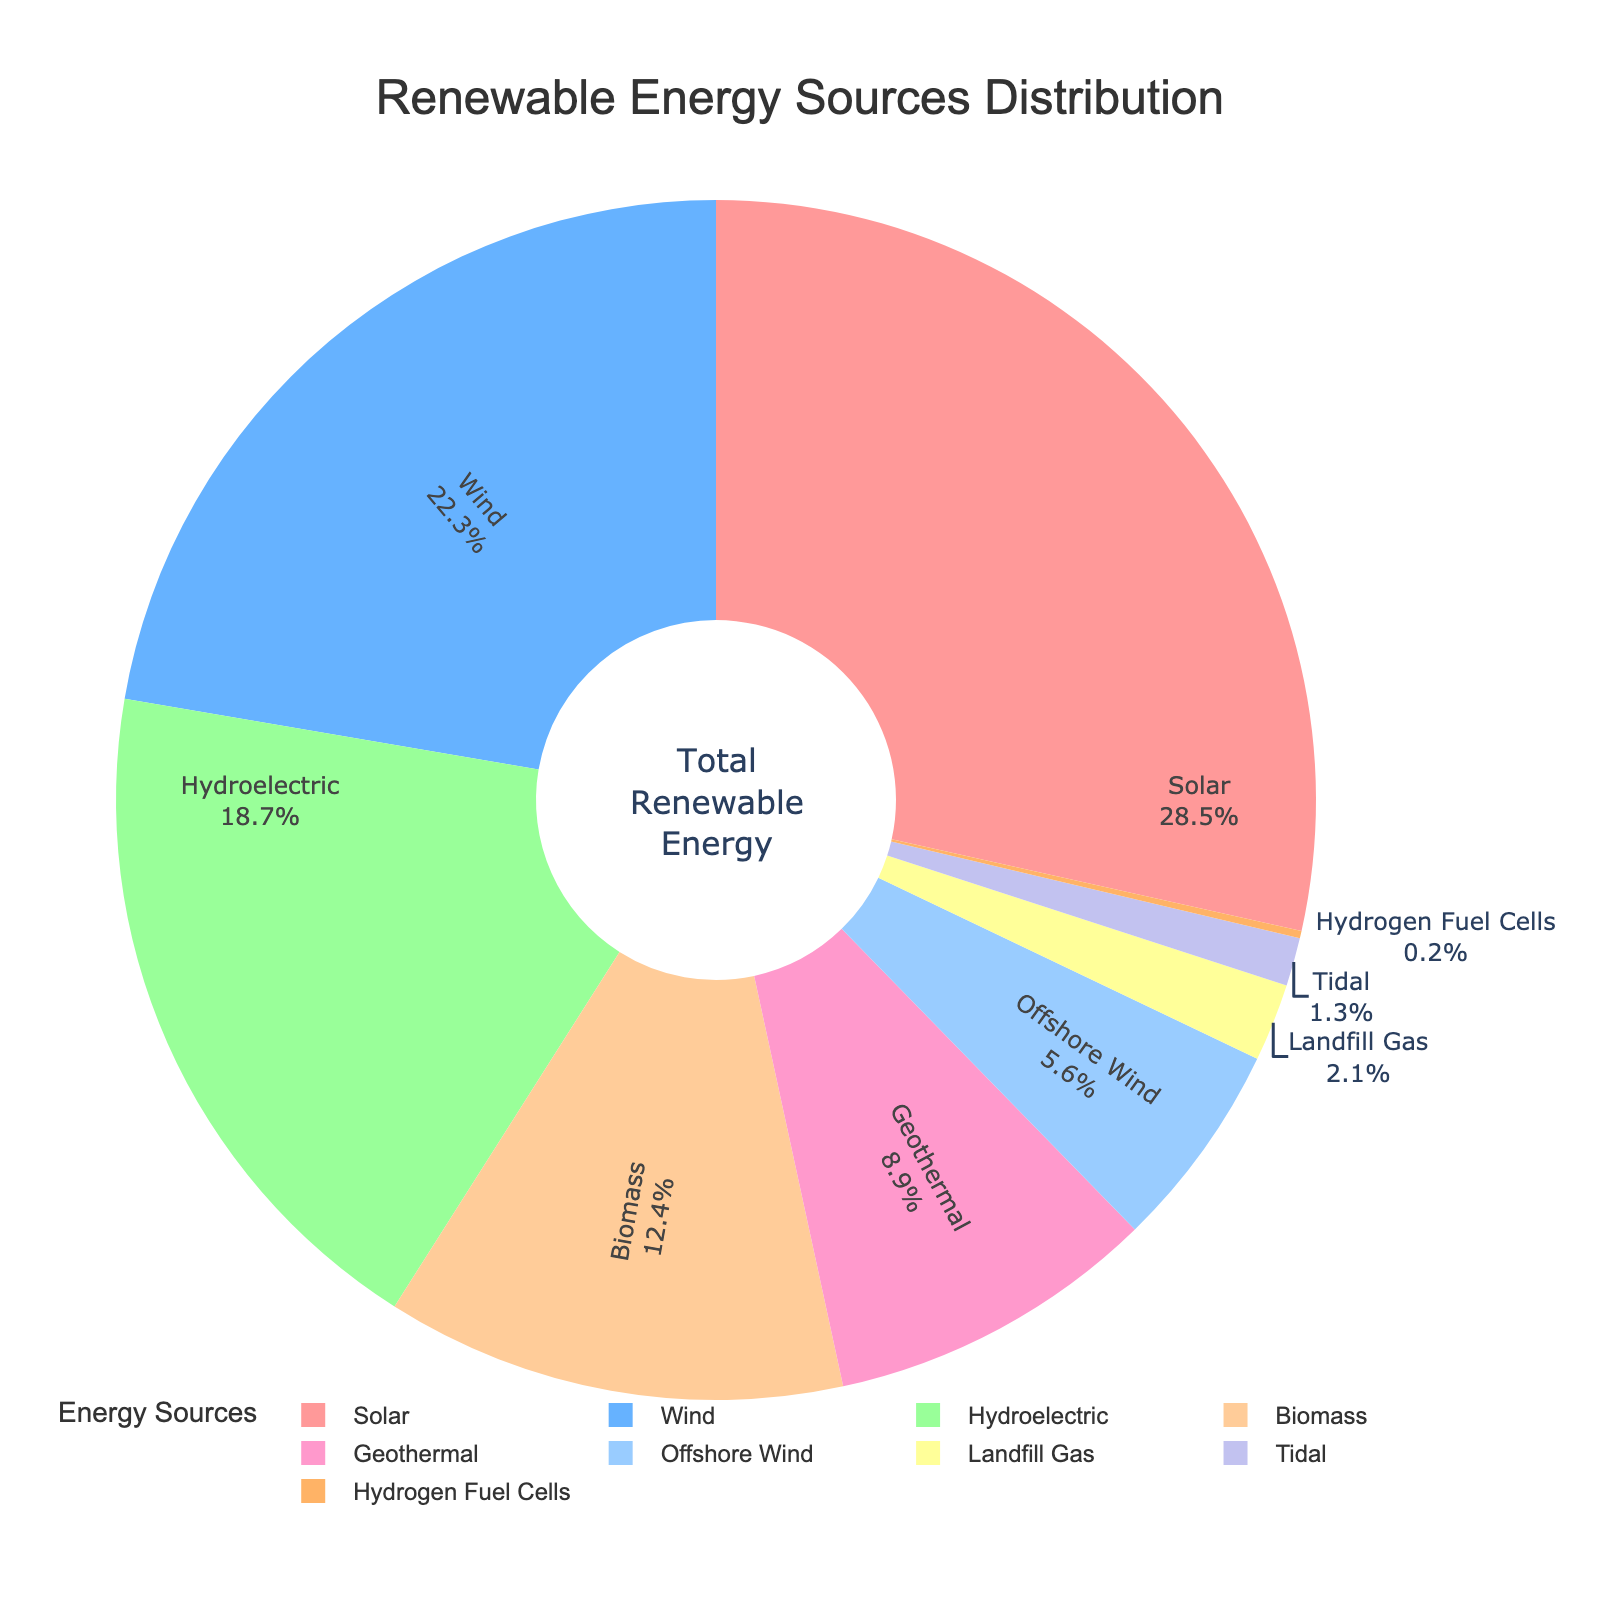Which energy source contributes the highest percentage? The pie chart shows the distribution of renewable energy sources. The segment with the largest percentage represents the highest contributor.
Answer: Solar What's the combined percentage of Wind and Offshore Wind? From the chart, Wind contributes 22.3% and Offshore Wind contributes 5.6%. Adding these percentages gives the total contribution. 22.3% + 5.6%
Answer: 27.9% Is Biomass contributing more or less than Geothermal? Biomass (12.4%) and Geothermal (8.9%) percentages can be compared directly from the chart.
Answer: More What is the difference in percentage between Solar and Hydroelectric? Solar contributes 28.5% and Hydroelectric 18.7%, the difference is calculated by subtracting Hydroelectric from Solar. 28.5% - 18.7%
Answer: 9.8% Which energy source, among the least contributors (below 3%), has the lowest percentage? The chart shows the contributions of Landfill Gas (2.1%), Tidal (1.3%), and Hydrogen Fuel Cells (0.2%). The smallest number among these is identified.
Answer: Hydrogen Fuel Cells What's the total percentage of energy sources contributing less than 10% each? Energy sources contributing less than 10% are Geothermal (8.9%), Offshore Wind (5.6%), Landfill Gas (2.1%), Tidal (1.3%), and Hydrogen Fuel Cells (0.2%). Summing these percentages: 8.9% + 5.6% + 2.1% + 1.3% + 0.2%
Answer: 18.1% Which color represents Hydroelectric energy in the pie chart? Visually identify the segment labeled "Hydroelectric" and describe its color.
Answer: Yellow If Solar and Wind energies contribute together, what would their percentage of the total renewable energy be? The sum of Solar (28.5%) and Wind (22.3%) contributions gives the combined percentage. 28.5% + 22.3%
Answer: 50.8% Which energy source, other than Solar, contributes more than 20% to the state's power grid? Identify the energy sources with contributions above 20%. Aside from Solar, Wind is the other source with a significant contribution (22.3%).
Answer: Wind What is the smallest contribution among the significant renewable energy sources contributing more than 10%? Among the energy sources contributing more than 10%: Solar (28.5%), Wind (22.3%), Hydroelectric (18.7%), and Biomass (12.4%). Identify the smallest number from these.
Answer: Biomass 